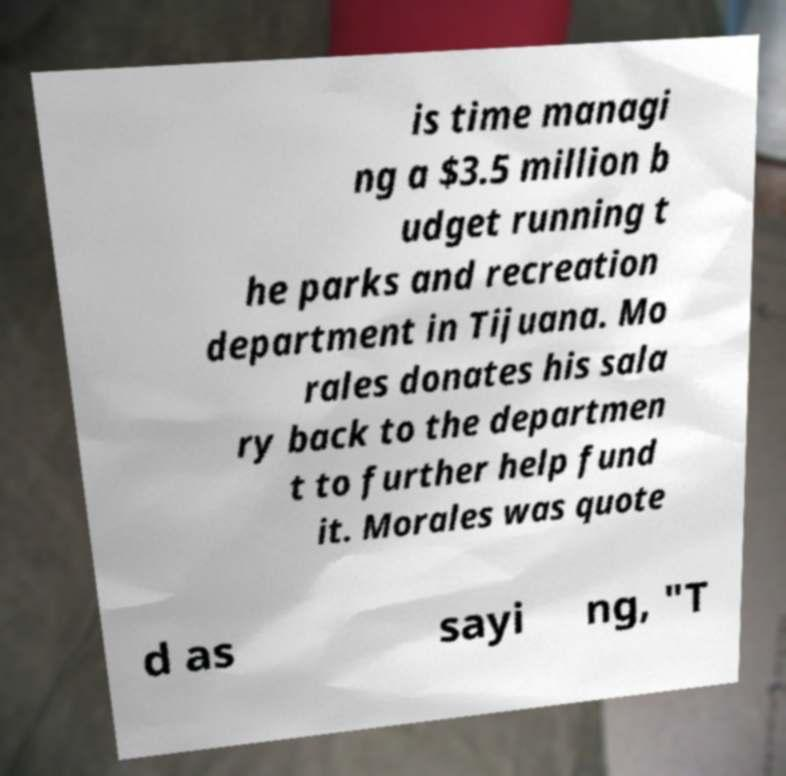Could you extract and type out the text from this image? is time managi ng a $3.5 million b udget running t he parks and recreation department in Tijuana. Mo rales donates his sala ry back to the departmen t to further help fund it. Morales was quote d as sayi ng, "T 